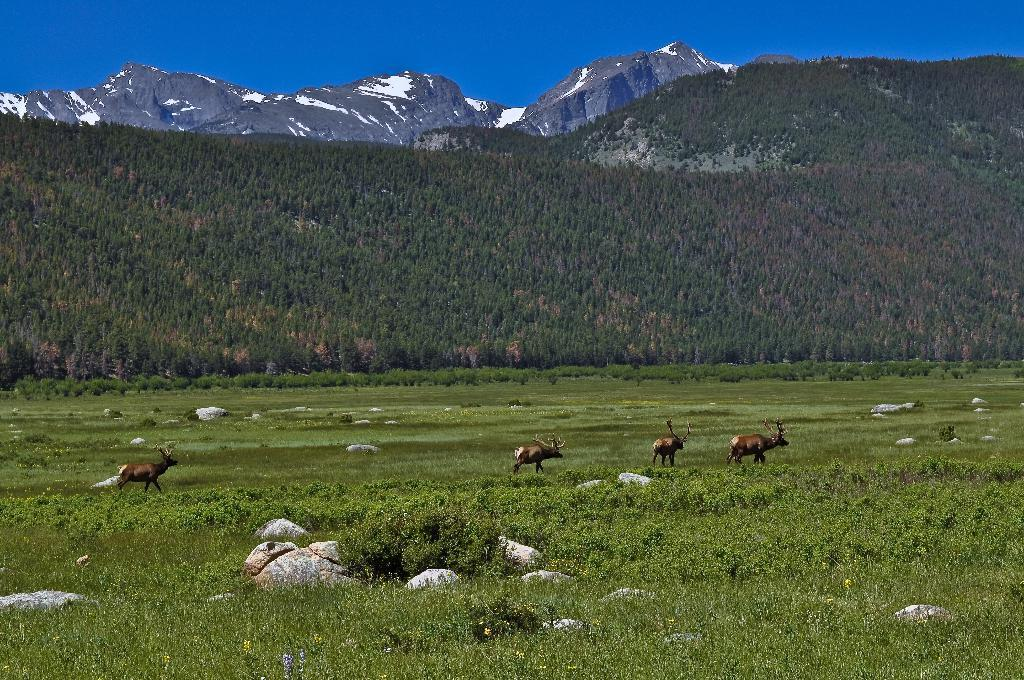What types of living organisms can be seen in the image? Animals and plants are visible in the image. What other natural elements can be seen in the image? Rocks, grass, trees, and hills are present in the image. What part of the natural environment is visible in the image? The sky is visible in the image. What type of credit can be seen on the animals in the image? There is no credit or labeling present on the animals in the image. How does the ship navigate through the hills in the image? There is no ship present in the image; it features animals, plants, rocks, grass, trees, hills, and the sky. 